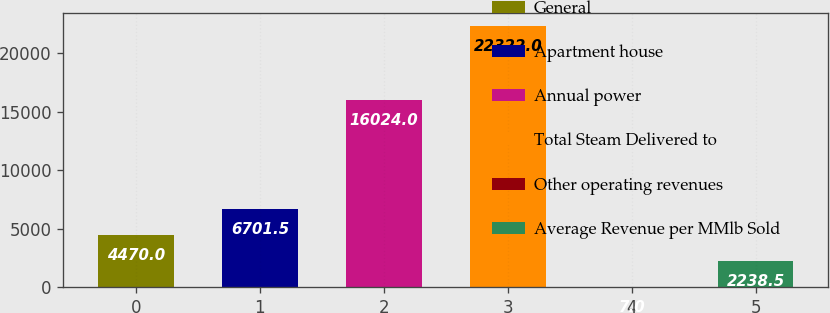Convert chart. <chart><loc_0><loc_0><loc_500><loc_500><bar_chart><fcel>General<fcel>Apartment house<fcel>Annual power<fcel>Total Steam Delivered to<fcel>Other operating revenues<fcel>Average Revenue per MMlb Sold<nl><fcel>4470<fcel>6701.5<fcel>16024<fcel>22322<fcel>7<fcel>2238.5<nl></chart> 